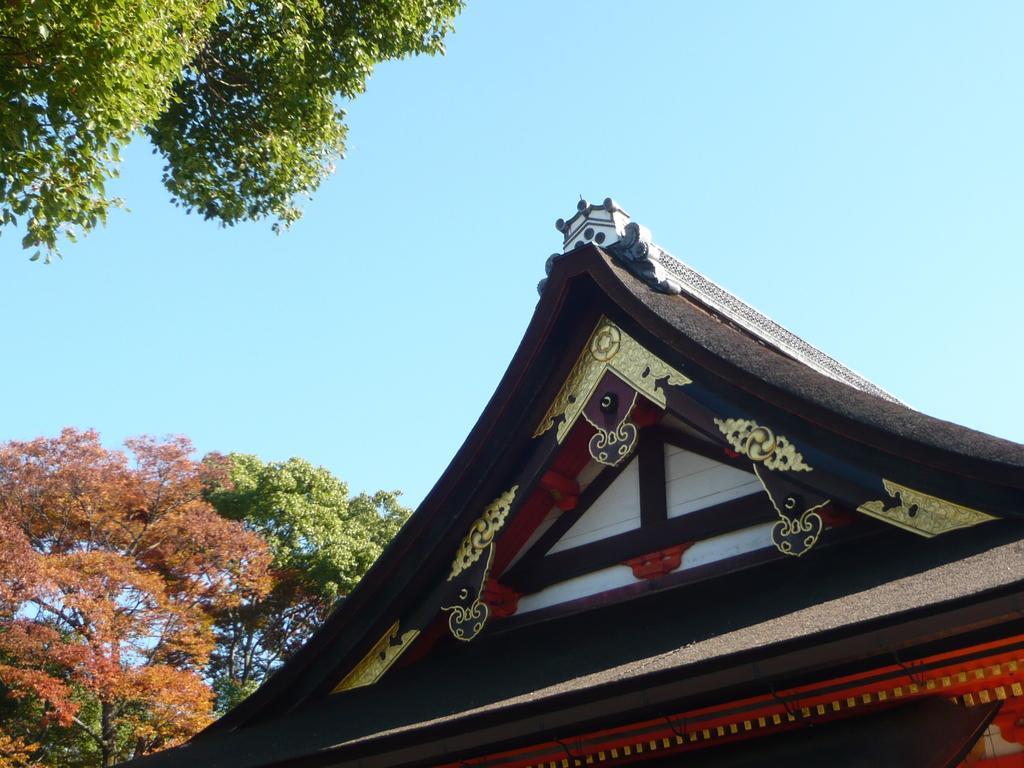Describe this image in one or two sentences. There is a Chinese house at the bottom of this image and there is one tree on the left side to this house. There is one another tree on the top left side of this image,and there is a sky in the background. 